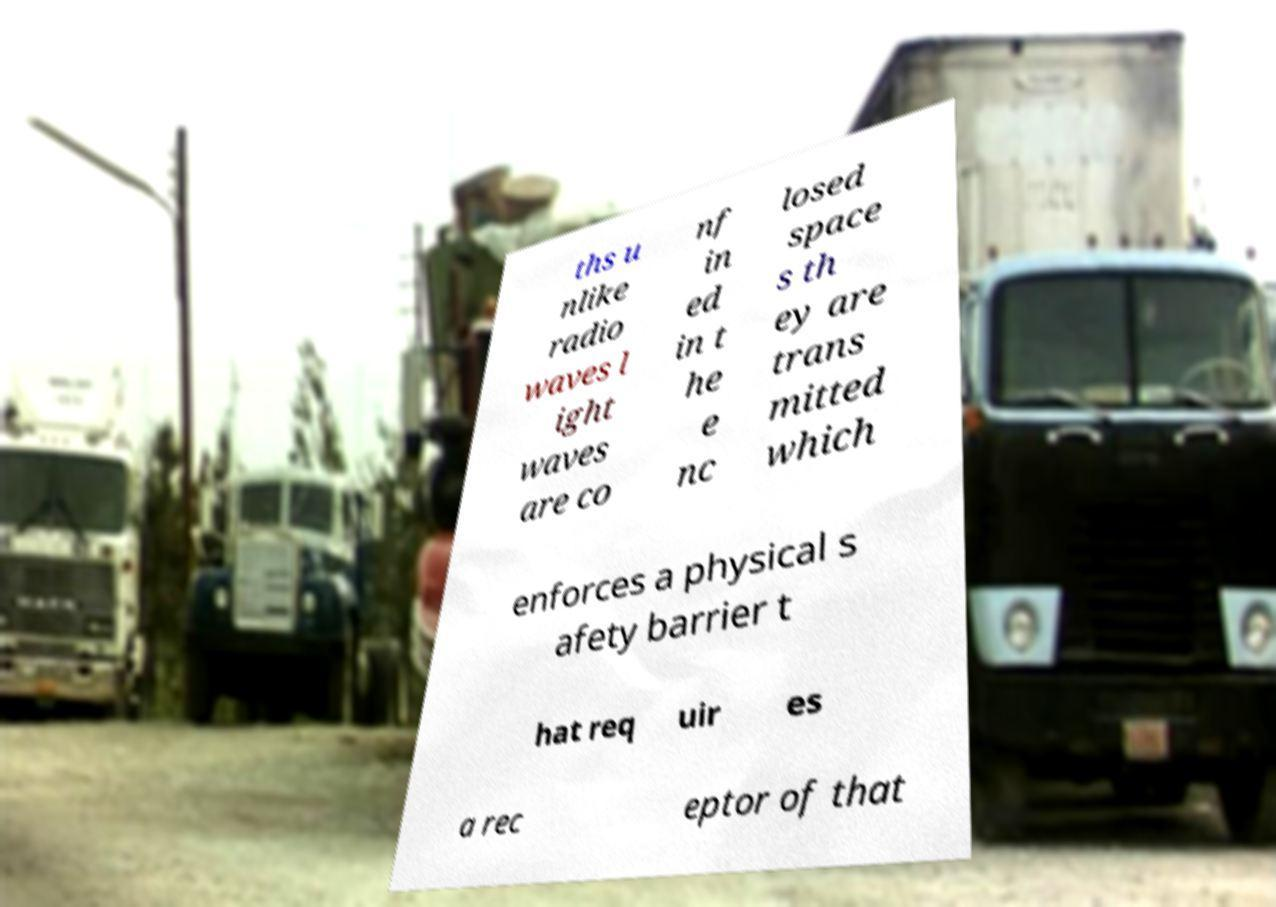Could you extract and type out the text from this image? ths u nlike radio waves l ight waves are co nf in ed in t he e nc losed space s th ey are trans mitted which enforces a physical s afety barrier t hat req uir es a rec eptor of that 